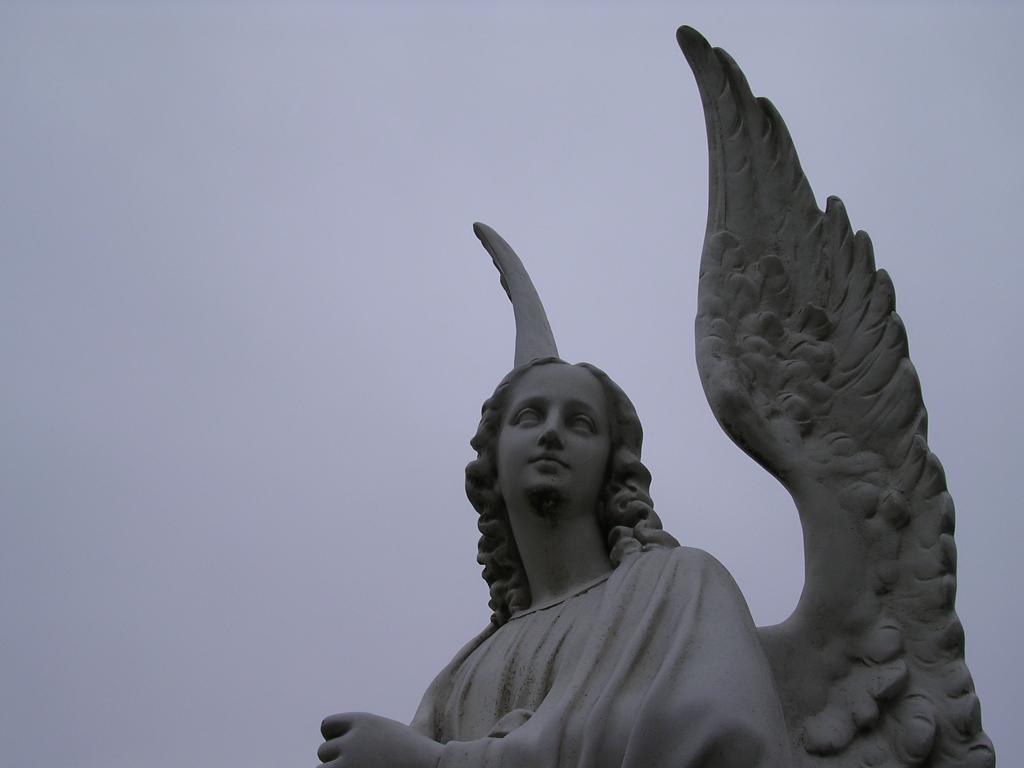Can you describe this image briefly? In this image there is a statue of a girl who is having the wings. At the top there is the sky. 